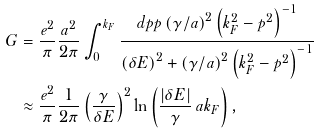<formula> <loc_0><loc_0><loc_500><loc_500>G & = \frac { e ^ { 2 } } { \pi } \frac { a ^ { 2 } } { 2 \pi } \int _ { 0 } ^ { k _ { F } } \frac { d p p \left ( \gamma / a \right ) ^ { 2 } \left ( k _ { F } ^ { 2 } - p ^ { 2 } \right ) ^ { - 1 } } { \left ( \delta E \right ) ^ { 2 } + \left ( \gamma / a \right ) ^ { 2 } \left ( k _ { F } ^ { 2 } - p ^ { 2 } \right ) ^ { - 1 } } \\ & \approx \frac { e ^ { 2 } } { \pi } \frac { 1 } { 2 \pi } \left ( \frac { \gamma } { \delta E } \right ) ^ { 2 } \ln \left ( \frac { | \delta E | } { \gamma } \, a k _ { F } \right ) ,</formula> 